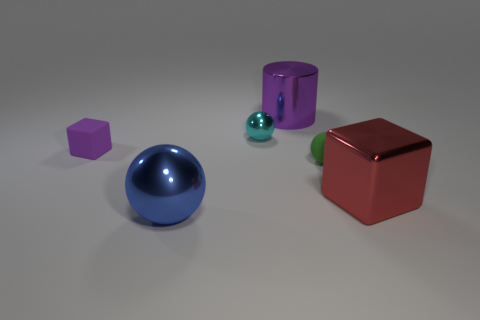Are there more blue cylinders than large blue shiny things?
Provide a succinct answer. No. There is a purple thing right of the metallic ball that is right of the blue sphere; how big is it?
Your response must be concise. Large. What color is the tiny thing that is the same shape as the big red thing?
Ensure brevity in your answer.  Purple. What size is the blue object?
Give a very brief answer. Large. What number of spheres are matte things or small cyan metal things?
Keep it short and to the point. 2. What size is the other metal thing that is the same shape as the tiny cyan shiny thing?
Your response must be concise. Large. How many big purple cylinders are there?
Ensure brevity in your answer.  1. Does the small purple matte thing have the same shape as the large object on the left side of the purple cylinder?
Your response must be concise. No. How big is the ball that is in front of the red cube?
Provide a succinct answer. Large. What is the tiny purple block made of?
Keep it short and to the point. Rubber. 